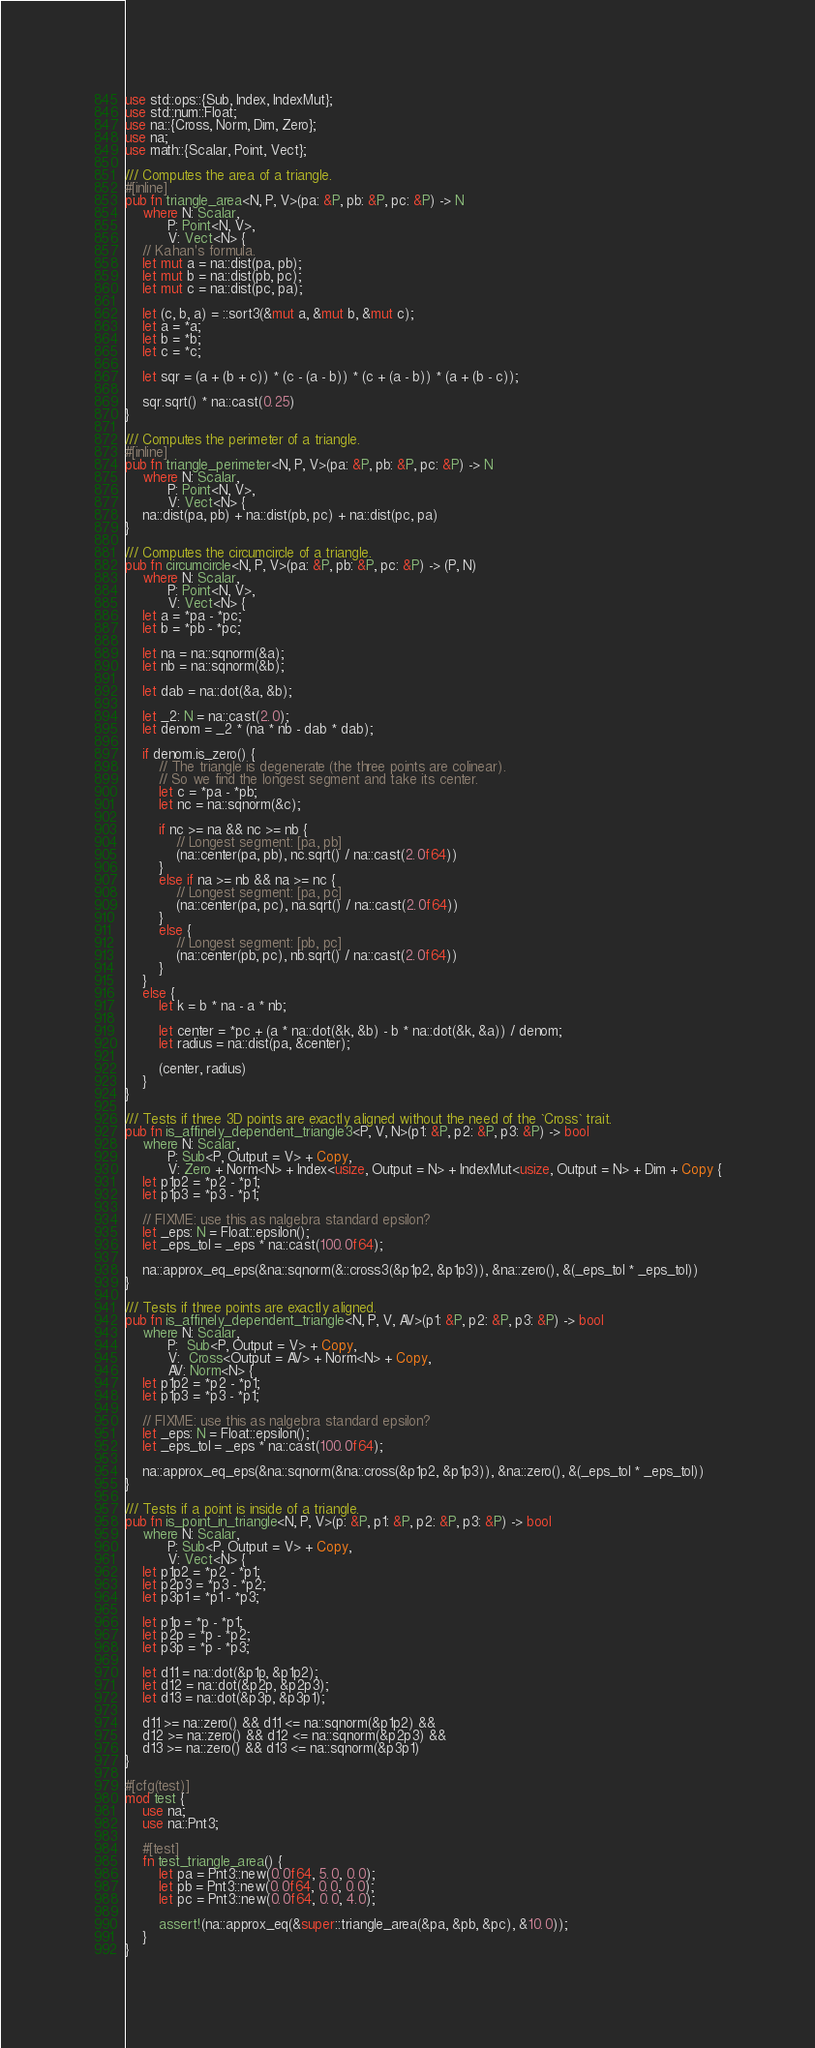<code> <loc_0><loc_0><loc_500><loc_500><_Rust_>use std::ops::{Sub, Index, IndexMut};
use std::num::Float;
use na::{Cross, Norm, Dim, Zero};
use na;
use math::{Scalar, Point, Vect};

/// Computes the area of a triangle.
#[inline]
pub fn triangle_area<N, P, V>(pa: &P, pb: &P, pc: &P) -> N
    where N: Scalar,
          P: Point<N, V>,
          V: Vect<N> {
    // Kahan's formula.
    let mut a = na::dist(pa, pb);
    let mut b = na::dist(pb, pc);
    let mut c = na::dist(pc, pa);

    let (c, b, a) = ::sort3(&mut a, &mut b, &mut c);
    let a = *a;
    let b = *b;
    let c = *c;

    let sqr = (a + (b + c)) * (c - (a - b)) * (c + (a - b)) * (a + (b - c));

    sqr.sqrt() * na::cast(0.25)
}

/// Computes the perimeter of a triangle.
#[inline]
pub fn triangle_perimeter<N, P, V>(pa: &P, pb: &P, pc: &P) -> N
    where N: Scalar,
          P: Point<N, V>,
          V: Vect<N> {
    na::dist(pa, pb) + na::dist(pb, pc) + na::dist(pc, pa)
}

/// Computes the circumcircle of a triangle.
pub fn circumcircle<N, P, V>(pa: &P, pb: &P, pc: &P) -> (P, N)
    where N: Scalar,
          P: Point<N, V>,
          V: Vect<N> {
    let a = *pa - *pc;
    let b = *pb - *pc;

    let na = na::sqnorm(&a);
    let nb = na::sqnorm(&b);

    let dab = na::dot(&a, &b);

    let _2: N = na::cast(2.0);
    let denom = _2 * (na * nb - dab * dab);

    if denom.is_zero() {
        // The triangle is degenerate (the three points are colinear).
        // So we find the longest segment and take its center.
        let c = *pa - *pb;
        let nc = na::sqnorm(&c);

        if nc >= na && nc >= nb {
            // Longest segment: [pa, pb]
            (na::center(pa, pb), nc.sqrt() / na::cast(2.0f64))
        }
        else if na >= nb && na >= nc {
            // Longest segment: [pa, pc]
            (na::center(pa, pc), na.sqrt() / na::cast(2.0f64))
        }
        else {
            // Longest segment: [pb, pc]
            (na::center(pb, pc), nb.sqrt() / na::cast(2.0f64))
        }
    }
    else {
        let k = b * na - a * nb;

        let center = *pc + (a * na::dot(&k, &b) - b * na::dot(&k, &a)) / denom;
        let radius = na::dist(pa, &center);

        (center, radius)
    }
}

/// Tests if three 3D points are exactly aligned without the need of the `Cross` trait.
pub fn is_affinely_dependent_triangle3<P, V, N>(p1: &P, p2: &P, p3: &P) -> bool
    where N: Scalar,
          P: Sub<P, Output = V> + Copy,
          V: Zero + Norm<N> + Index<usize, Output = N> + IndexMut<usize, Output = N> + Dim + Copy {
    let p1p2 = *p2 - *p1;
    let p1p3 = *p3 - *p1;

    // FIXME: use this as nalgebra standard epsilon?
    let _eps: N = Float::epsilon();
    let _eps_tol = _eps * na::cast(100.0f64);

    na::approx_eq_eps(&na::sqnorm(&::cross3(&p1p2, &p1p3)), &na::zero(), &(_eps_tol * _eps_tol))
}

/// Tests if three points are exactly aligned.
pub fn is_affinely_dependent_triangle<N, P, V, AV>(p1: &P, p2: &P, p3: &P) -> bool
    where N: Scalar,
          P:  Sub<P, Output = V> + Copy,
          V:  Cross<Output = AV> + Norm<N> + Copy,
          AV: Norm<N> {
    let p1p2 = *p2 - *p1;
    let p1p3 = *p3 - *p1;

    // FIXME: use this as nalgebra standard epsilon?
    let _eps: N = Float::epsilon();
    let _eps_tol = _eps * na::cast(100.0f64);

    na::approx_eq_eps(&na::sqnorm(&na::cross(&p1p2, &p1p3)), &na::zero(), &(_eps_tol * _eps_tol))
}

/// Tests if a point is inside of a triangle.
pub fn is_point_in_triangle<N, P, V>(p: &P, p1: &P, p2: &P, p3: &P) -> bool
    where N: Scalar,
          P: Sub<P, Output = V> + Copy,
          V: Vect<N> {
    let p1p2 = *p2 - *p1;
    let p2p3 = *p3 - *p2;
    let p3p1 = *p1 - *p3;

    let p1p = *p - *p1;
    let p2p = *p - *p2;
    let p3p = *p - *p3;

    let d11 = na::dot(&p1p, &p1p2);
    let d12 = na::dot(&p2p, &p2p3);
    let d13 = na::dot(&p3p, &p3p1);

    d11 >= na::zero() && d11 <= na::sqnorm(&p1p2) &&
    d12 >= na::zero() && d12 <= na::sqnorm(&p2p3) &&
    d13 >= na::zero() && d13 <= na::sqnorm(&p3p1)
}

#[cfg(test)]
mod test {
    use na;
    use na::Pnt3;

    #[test]
    fn test_triangle_area() {
        let pa = Pnt3::new(0.0f64, 5.0, 0.0);
        let pb = Pnt3::new(0.0f64, 0.0, 0.0);
        let pc = Pnt3::new(0.0f64, 0.0, 4.0);

        assert!(na::approx_eq(&super::triangle_area(&pa, &pb, &pc), &10.0));
    }
}
</code> 